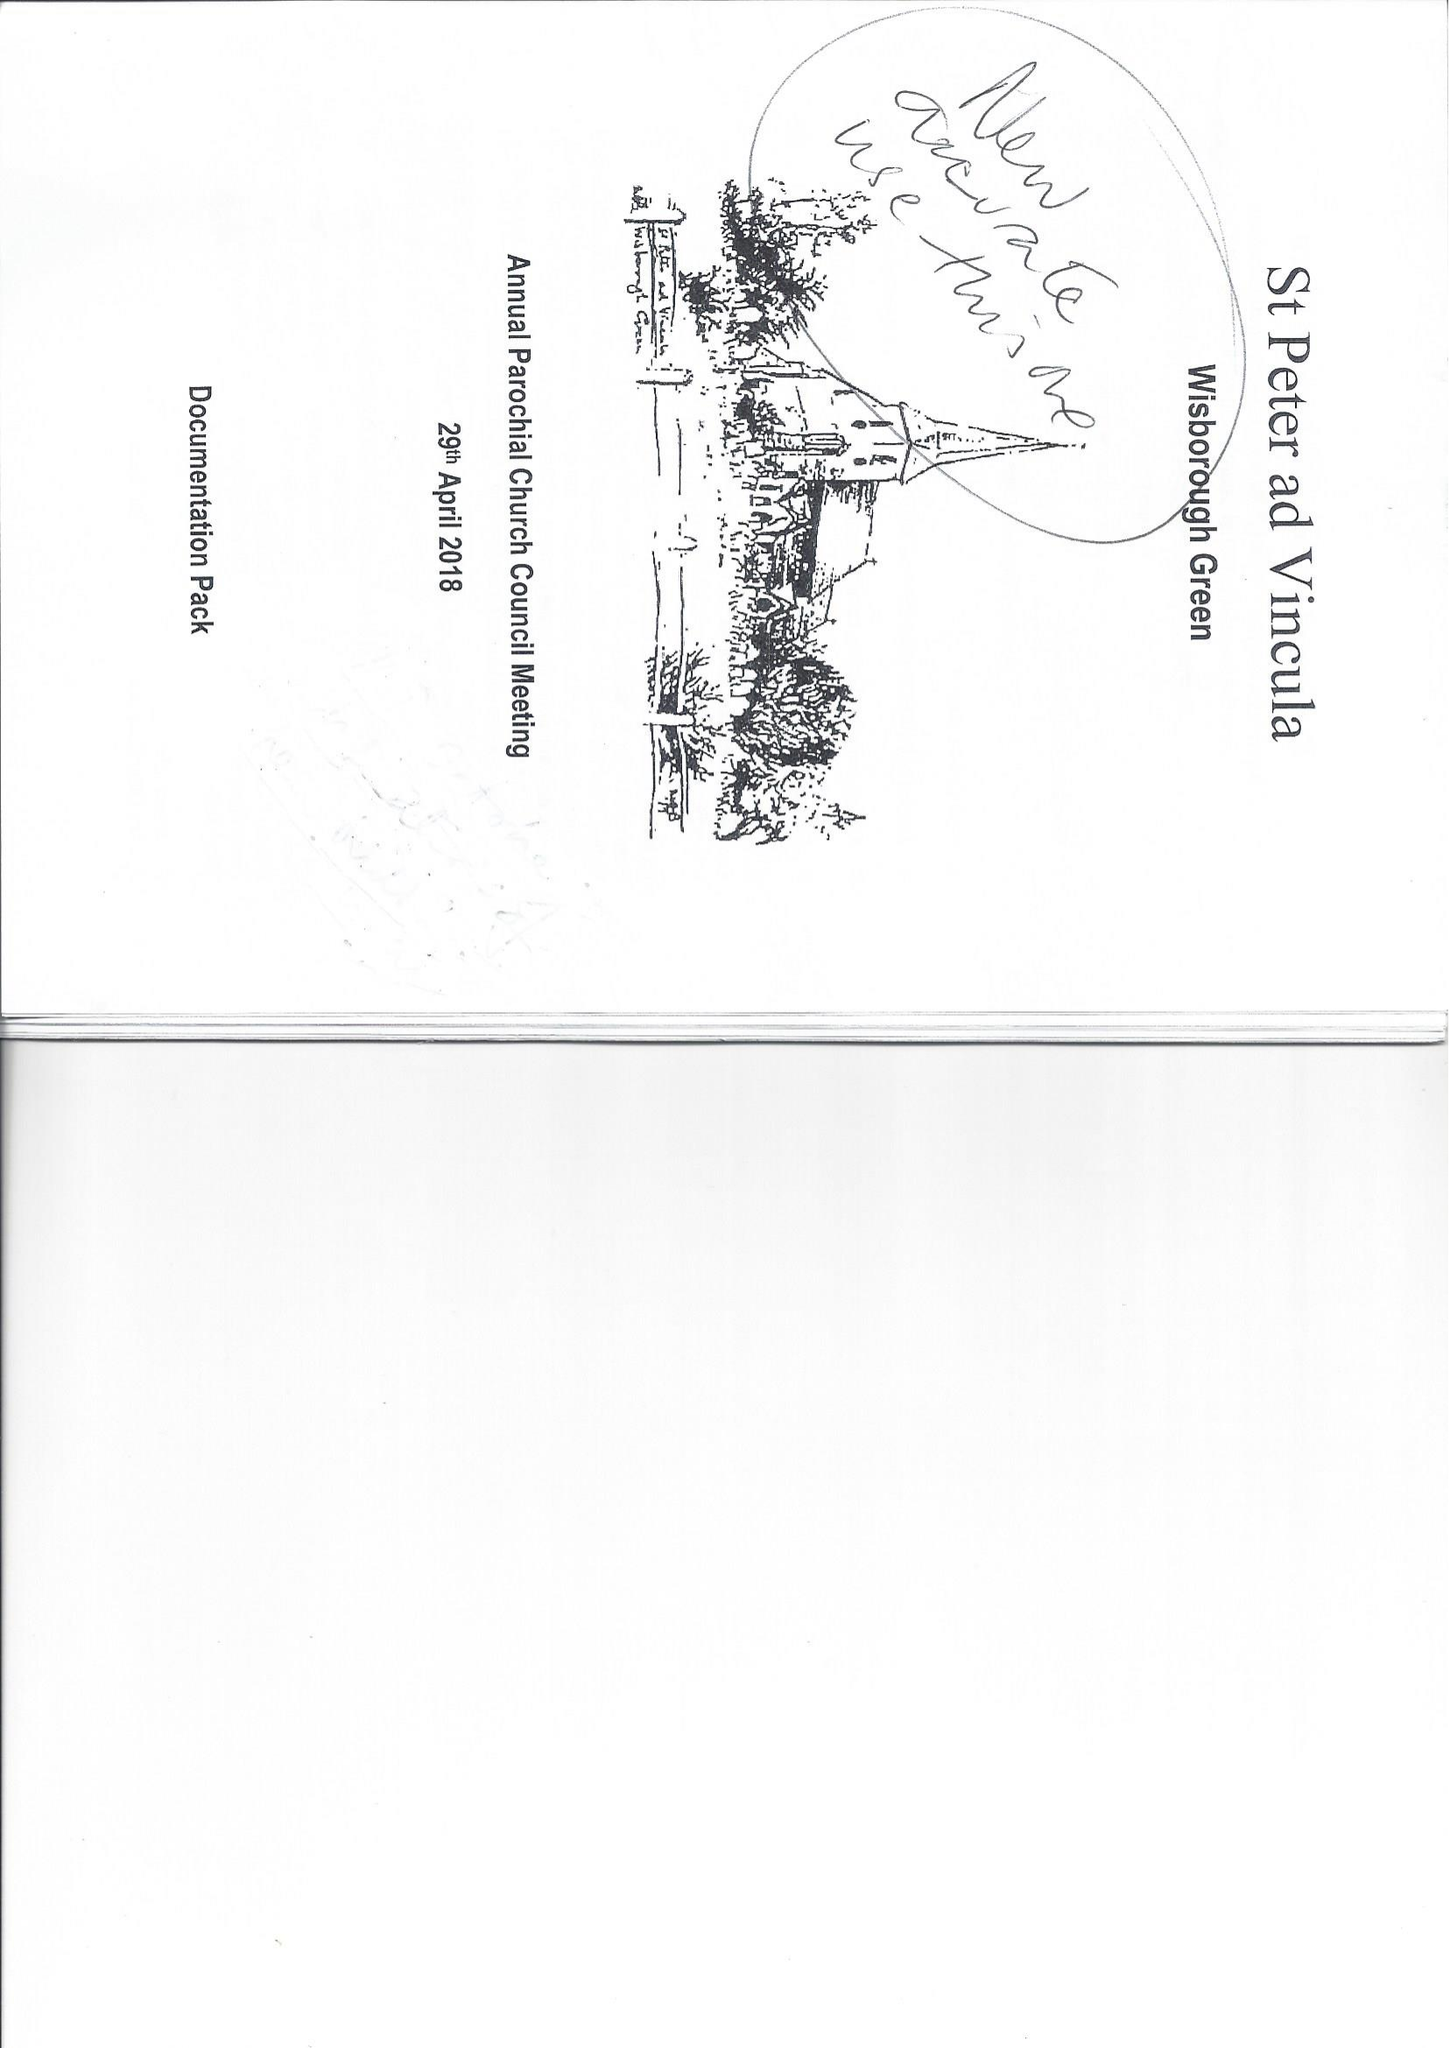What is the value for the address__street_line?
Answer the question using a single word or phrase. None 